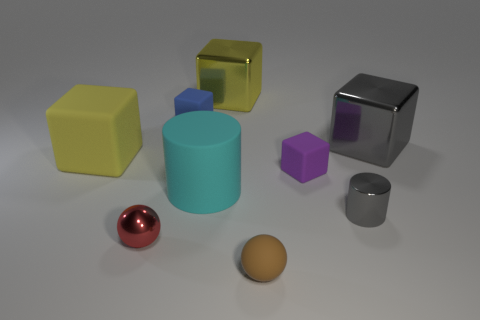What shape is the metallic thing that is the same color as the small cylinder?
Offer a very short reply. Cube. How many things are either tiny rubber cubes that are on the left side of the tiny purple object or large red cubes?
Provide a short and direct response. 1. There is a shiny object that is both to the left of the small gray cylinder and behind the large cyan rubber cylinder; how big is it?
Provide a succinct answer. Large. There is a shiny block that is the same color as the large rubber cube; what size is it?
Give a very brief answer. Large. How many other things are there of the same size as the red metal thing?
Provide a short and direct response. 4. What color is the tiny metallic thing on the right side of the small matte cube that is in front of the big thing to the right of the brown ball?
Ensure brevity in your answer.  Gray. What shape is the shiny thing that is both to the right of the purple rubber cube and in front of the big cyan rubber cylinder?
Give a very brief answer. Cylinder. How many other objects are there of the same shape as the small blue rubber object?
Your answer should be very brief. 4. What shape is the matte thing that is in front of the metallic object in front of the gray metallic object in front of the big yellow rubber thing?
Provide a short and direct response. Sphere. What number of things are either large cyan rubber spheres or yellow blocks left of the small metallic ball?
Make the answer very short. 1. 